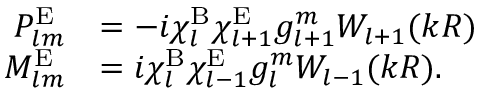Convert formula to latex. <formula><loc_0><loc_0><loc_500><loc_500>\begin{array} { r l } { P _ { l m } ^ { E } } & { = - i \chi _ { l } ^ { B } \chi _ { l + 1 } ^ { E } g _ { l + 1 } ^ { m } W _ { l + 1 } ( k R ) } \\ { M _ { l m } ^ { E } } & { = i \chi _ { l } ^ { B } \chi _ { l - 1 } ^ { E } g _ { l } ^ { m } W _ { l - 1 } ( k R ) . } \end{array}</formula> 